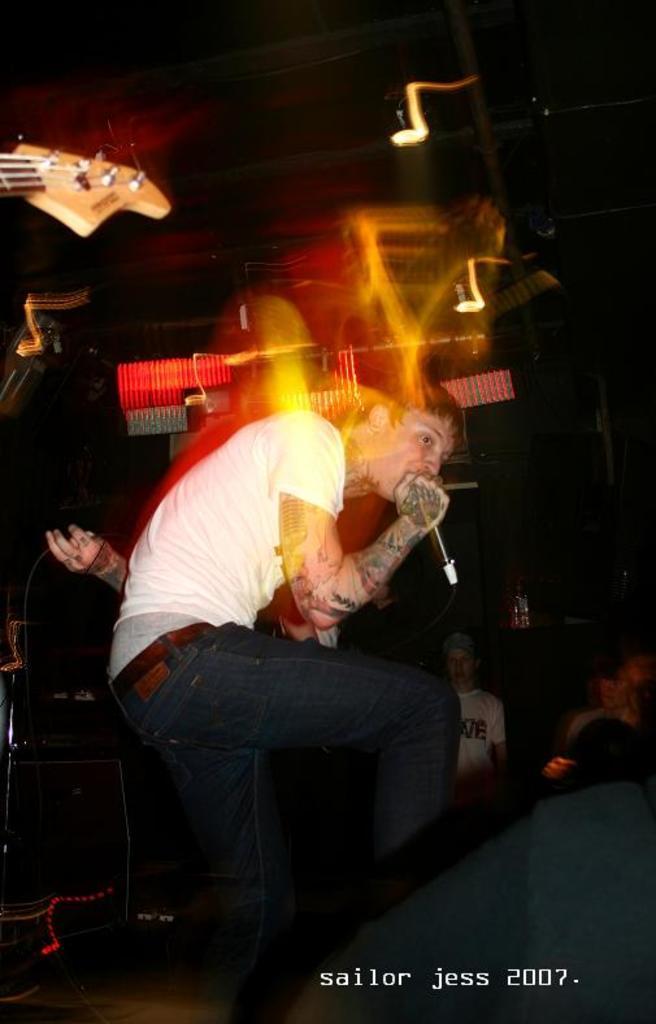Please provide a concise description of this image. This looks like an edited image. I can see a man standing and singing a song by holding a mike. I can see a guitar at the left corner of the image. At background I can see few people standing. 